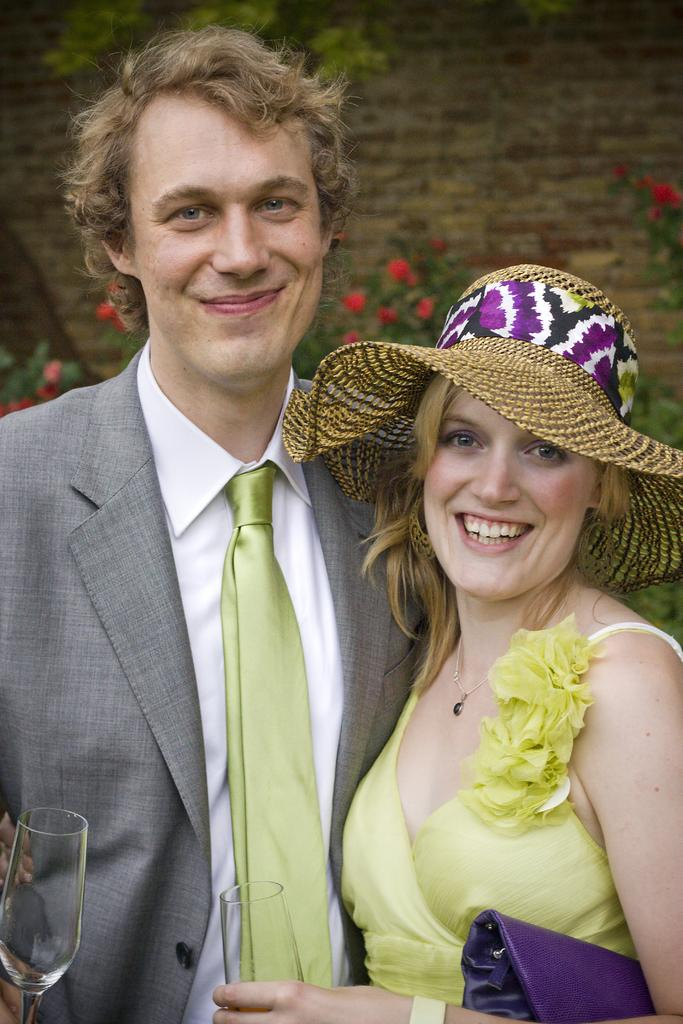How many people are in the image? There are two people in the image, a girl and a boy. What are the girl and boy doing in the image? The girl and boy are standing beside each other. What objects are the girl and boy holding in the image? The girl and boy are holding wine glasses. What is the girl wearing on her head in the image? The girl is wearing a hat. What type of ornament is hanging from the boy's ear in the image? There is no ornament hanging from the boy's ear in the image; he is not wearing any visible earrings or accessories. 